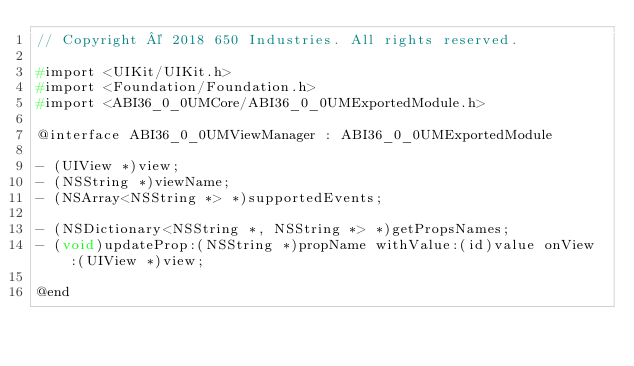Convert code to text. <code><loc_0><loc_0><loc_500><loc_500><_C_>// Copyright © 2018 650 Industries. All rights reserved.

#import <UIKit/UIKit.h>
#import <Foundation/Foundation.h>
#import <ABI36_0_0UMCore/ABI36_0_0UMExportedModule.h>

@interface ABI36_0_0UMViewManager : ABI36_0_0UMExportedModule

- (UIView *)view;
- (NSString *)viewName;
- (NSArray<NSString *> *)supportedEvents;

- (NSDictionary<NSString *, NSString *> *)getPropsNames;
- (void)updateProp:(NSString *)propName withValue:(id)value onView:(UIView *)view;

@end
</code> 